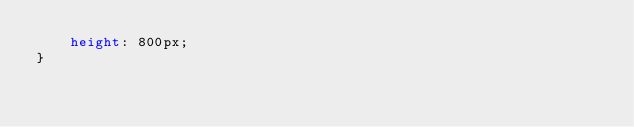<code> <loc_0><loc_0><loc_500><loc_500><_CSS_>    height: 800px;
}</code> 